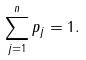<formula> <loc_0><loc_0><loc_500><loc_500>\sum _ { j = 1 } ^ { n } p _ { j } = 1 .</formula> 